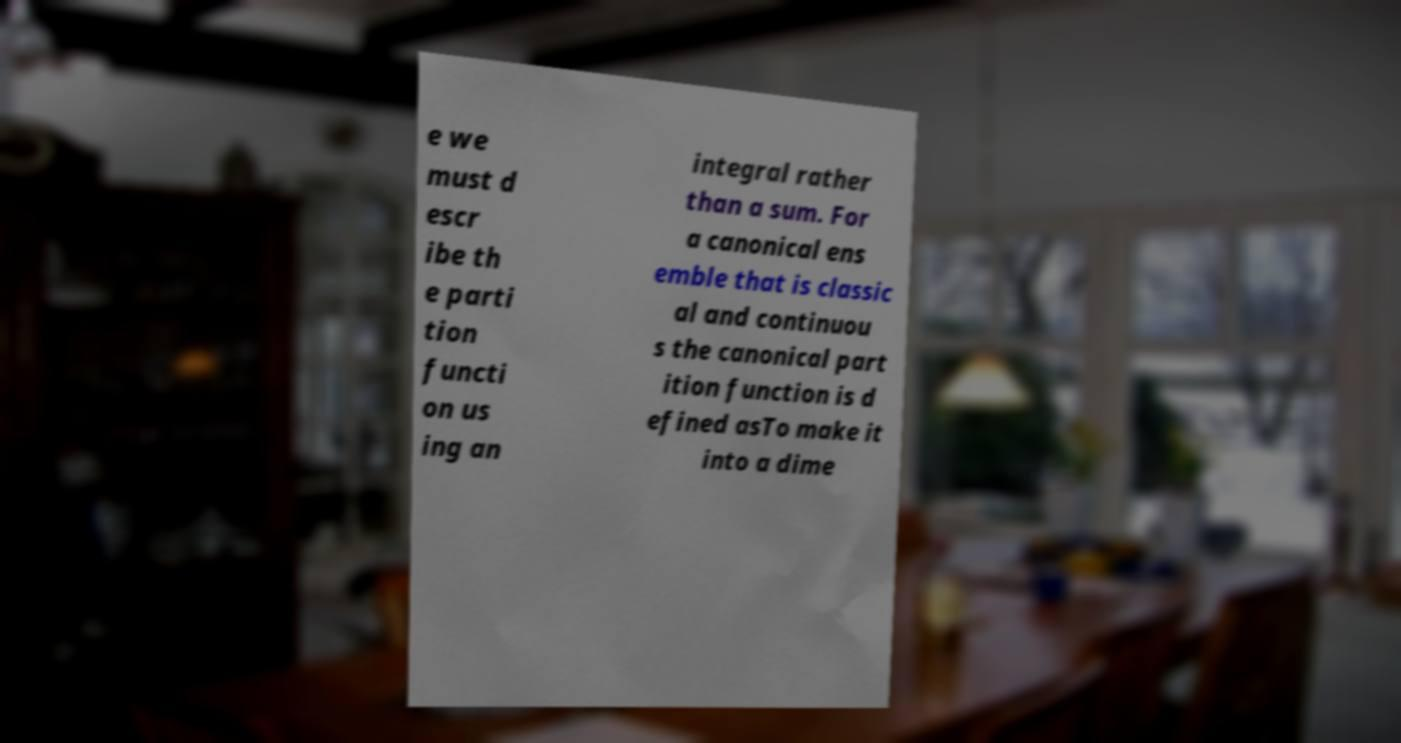There's text embedded in this image that I need extracted. Can you transcribe it verbatim? e we must d escr ibe th e parti tion functi on us ing an integral rather than a sum. For a canonical ens emble that is classic al and continuou s the canonical part ition function is d efined asTo make it into a dime 